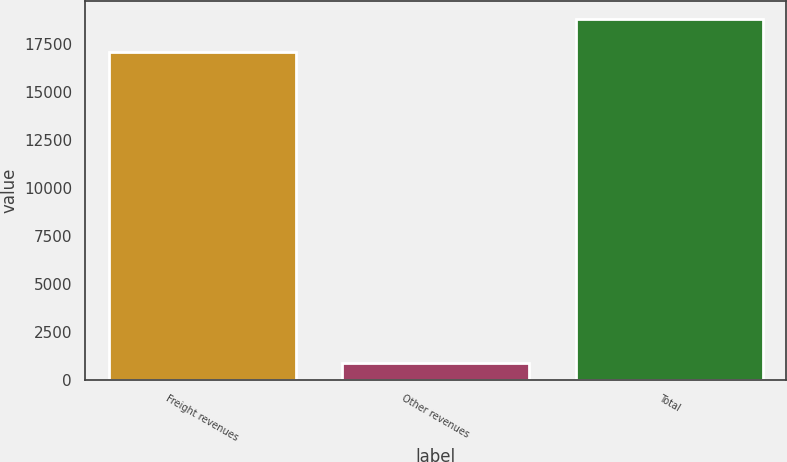Convert chart. <chart><loc_0><loc_0><loc_500><loc_500><bar_chart><fcel>Freight revenues<fcel>Other revenues<fcel>Total<nl><fcel>17118<fcel>852<fcel>18829.8<nl></chart> 